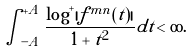<formula> <loc_0><loc_0><loc_500><loc_500>\int _ { - A } ^ { + A } \frac { \log ^ { + } | f ^ { m n } ( t ) | } { 1 + t ^ { 2 } } d t < \infty .</formula> 